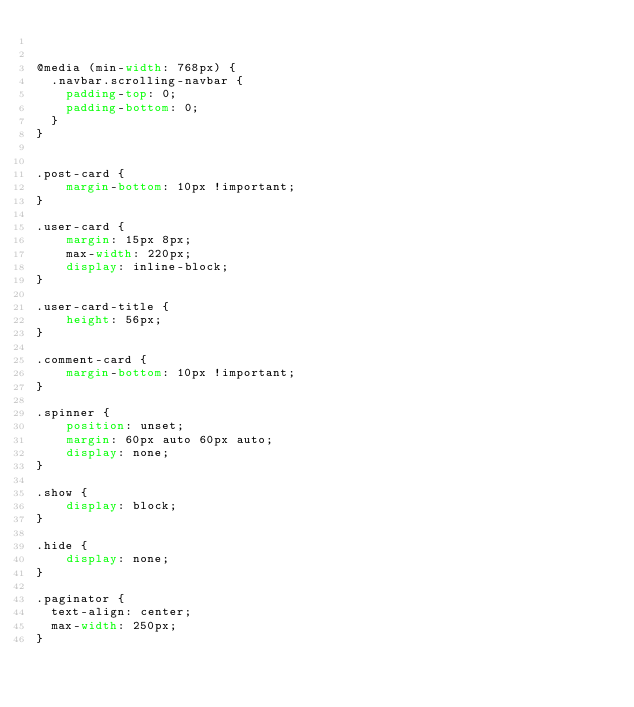<code> <loc_0><loc_0><loc_500><loc_500><_CSS_>

@media (min-width: 768px) {
  .navbar.scrolling-navbar {
    padding-top: 0;
    padding-bottom: 0;
  }
}


.post-card {
    margin-bottom: 10px !important;
}

.user-card {
    margin: 15px 8px;
    max-width: 220px;
    display: inline-block;
}

.user-card-title {
    height: 56px;
}

.comment-card {
    margin-bottom: 10px !important;
}

.spinner {
    position: unset;
    margin: 60px auto 60px auto;
    display: none;
}

.show {
    display: block;
}

.hide {
    display: none;
}

.paginator {
  text-align: center;
  max-width: 250px;
}
</code> 